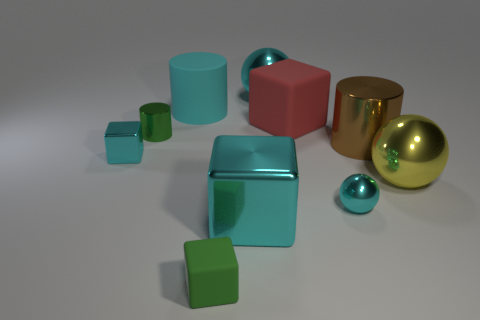Subtract all green shiny cylinders. How many cylinders are left? 2 Subtract all yellow cylinders. How many cyan cubes are left? 2 Subtract 3 cylinders. How many cylinders are left? 0 Subtract all cylinders. How many objects are left? 7 Subtract all cyan spheres. Subtract all cyan cylinders. How many spheres are left? 1 Subtract all gray shiny cubes. Subtract all big red matte things. How many objects are left? 9 Add 3 large yellow spheres. How many large yellow spheres are left? 4 Add 3 big cyan cubes. How many big cyan cubes exist? 4 Subtract all green cubes. How many cubes are left? 3 Subtract 0 red cylinders. How many objects are left? 10 